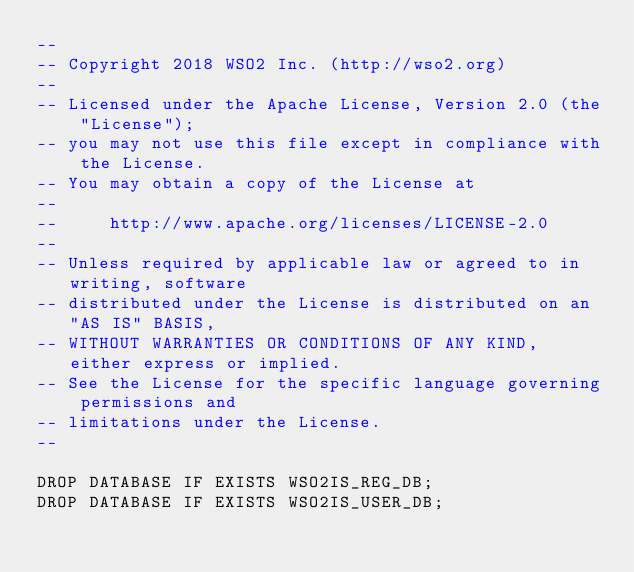Convert code to text. <code><loc_0><loc_0><loc_500><loc_500><_SQL_>--
-- Copyright 2018 WSO2 Inc. (http://wso2.org)
--
-- Licensed under the Apache License, Version 2.0 (the "License");
-- you may not use this file except in compliance with the License.
-- You may obtain a copy of the License at
--
--     http://www.apache.org/licenses/LICENSE-2.0
--
-- Unless required by applicable law or agreed to in writing, software
-- distributed under the License is distributed on an "AS IS" BASIS,
-- WITHOUT WARRANTIES OR CONDITIONS OF ANY KIND, either express or implied.
-- See the License for the specific language governing permissions and
-- limitations under the License.
--

DROP DATABASE IF EXISTS WSO2IS_REG_DB;
DROP DATABASE IF EXISTS WSO2IS_USER_DB;</code> 